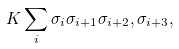Convert formula to latex. <formula><loc_0><loc_0><loc_500><loc_500>K \sum _ { i } \sigma _ { i } \sigma _ { i + 1 } \sigma _ { i + 2 } , \sigma _ { i + 3 } ,</formula> 